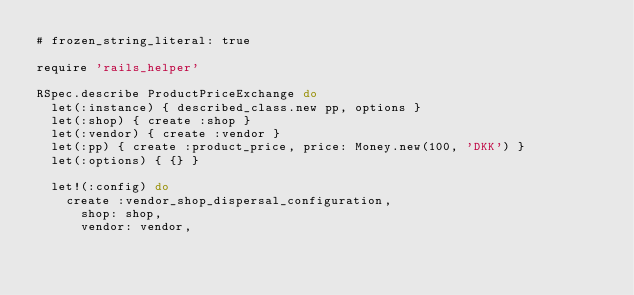<code> <loc_0><loc_0><loc_500><loc_500><_Ruby_># frozen_string_literal: true

require 'rails_helper'

RSpec.describe ProductPriceExchange do
  let(:instance) { described_class.new pp, options }
  let(:shop) { create :shop }
  let(:vendor) { create :vendor }
  let(:pp) { create :product_price, price: Money.new(100, 'DKK') }
  let(:options) { {} }

  let!(:config) do
    create :vendor_shop_dispersal_configuration,
      shop: shop,
      vendor: vendor,</code> 